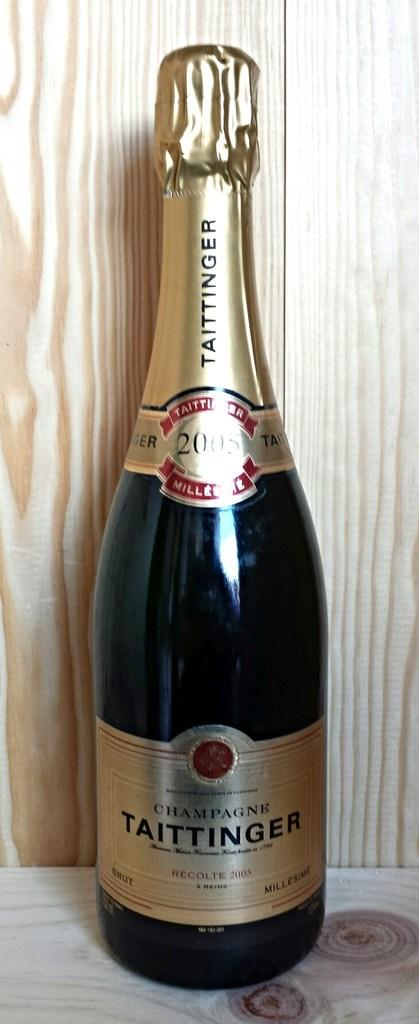<image>
Relay a brief, clear account of the picture shown. A champagne bottle of Taittinger is on display with a wooden base and wooden background. 